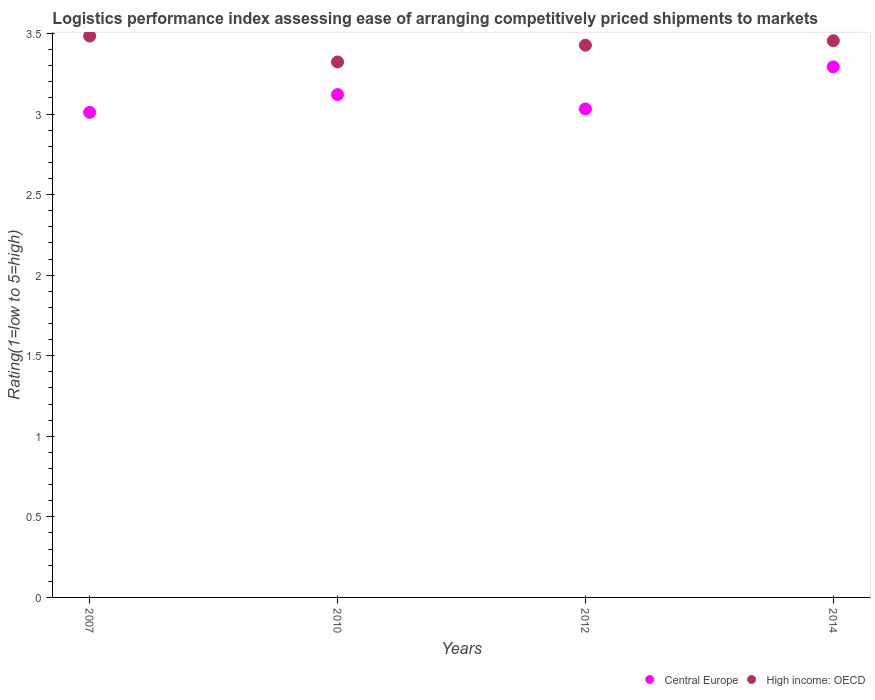What is the Logistic performance index in High income: OECD in 2010?
Provide a succinct answer. 3.32. Across all years, what is the maximum Logistic performance index in High income: OECD?
Ensure brevity in your answer.  3.48. Across all years, what is the minimum Logistic performance index in Central Europe?
Provide a short and direct response. 3.01. In which year was the Logistic performance index in High income: OECD maximum?
Offer a terse response. 2007. What is the total Logistic performance index in High income: OECD in the graph?
Provide a short and direct response. 13.69. What is the difference between the Logistic performance index in Central Europe in 2010 and that in 2014?
Provide a short and direct response. -0.17. What is the difference between the Logistic performance index in High income: OECD in 2014 and the Logistic performance index in Central Europe in 2010?
Your answer should be very brief. 0.33. What is the average Logistic performance index in High income: OECD per year?
Your answer should be very brief. 3.42. In the year 2010, what is the difference between the Logistic performance index in Central Europe and Logistic performance index in High income: OECD?
Offer a very short reply. -0.2. What is the ratio of the Logistic performance index in High income: OECD in 2007 to that in 2012?
Offer a very short reply. 1.02. Is the Logistic performance index in Central Europe in 2010 less than that in 2012?
Make the answer very short. No. Is the difference between the Logistic performance index in Central Europe in 2012 and 2014 greater than the difference between the Logistic performance index in High income: OECD in 2012 and 2014?
Keep it short and to the point. No. What is the difference between the highest and the second highest Logistic performance index in Central Europe?
Your answer should be very brief. 0.17. What is the difference between the highest and the lowest Logistic performance index in Central Europe?
Your response must be concise. 0.28. In how many years, is the Logistic performance index in High income: OECD greater than the average Logistic performance index in High income: OECD taken over all years?
Keep it short and to the point. 3. Is the sum of the Logistic performance index in Central Europe in 2010 and 2014 greater than the maximum Logistic performance index in High income: OECD across all years?
Your answer should be very brief. Yes. Does the Logistic performance index in Central Europe monotonically increase over the years?
Offer a very short reply. No. How many dotlines are there?
Ensure brevity in your answer.  2. Are the values on the major ticks of Y-axis written in scientific E-notation?
Your answer should be compact. No. Does the graph contain any zero values?
Provide a short and direct response. No. Does the graph contain grids?
Your answer should be very brief. No. Where does the legend appear in the graph?
Offer a very short reply. Bottom right. What is the title of the graph?
Give a very brief answer. Logistics performance index assessing ease of arranging competitively priced shipments to markets. What is the label or title of the Y-axis?
Your response must be concise. Rating(1=low to 5=high). What is the Rating(1=low to 5=high) in Central Europe in 2007?
Your response must be concise. 3.01. What is the Rating(1=low to 5=high) in High income: OECD in 2007?
Your answer should be very brief. 3.48. What is the Rating(1=low to 5=high) in Central Europe in 2010?
Your answer should be very brief. 3.12. What is the Rating(1=low to 5=high) in High income: OECD in 2010?
Provide a short and direct response. 3.32. What is the Rating(1=low to 5=high) of Central Europe in 2012?
Your answer should be very brief. 3.03. What is the Rating(1=low to 5=high) in High income: OECD in 2012?
Give a very brief answer. 3.43. What is the Rating(1=low to 5=high) of Central Europe in 2014?
Provide a succinct answer. 3.29. What is the Rating(1=low to 5=high) in High income: OECD in 2014?
Your answer should be compact. 3.45. Across all years, what is the maximum Rating(1=low to 5=high) of Central Europe?
Make the answer very short. 3.29. Across all years, what is the maximum Rating(1=low to 5=high) of High income: OECD?
Offer a terse response. 3.48. Across all years, what is the minimum Rating(1=low to 5=high) of Central Europe?
Provide a succinct answer. 3.01. Across all years, what is the minimum Rating(1=low to 5=high) of High income: OECD?
Your answer should be very brief. 3.32. What is the total Rating(1=low to 5=high) of Central Europe in the graph?
Offer a terse response. 12.46. What is the total Rating(1=low to 5=high) in High income: OECD in the graph?
Your answer should be very brief. 13.69. What is the difference between the Rating(1=low to 5=high) in Central Europe in 2007 and that in 2010?
Provide a succinct answer. -0.11. What is the difference between the Rating(1=low to 5=high) of High income: OECD in 2007 and that in 2010?
Ensure brevity in your answer.  0.16. What is the difference between the Rating(1=low to 5=high) of Central Europe in 2007 and that in 2012?
Offer a very short reply. -0.02. What is the difference between the Rating(1=low to 5=high) in High income: OECD in 2007 and that in 2012?
Give a very brief answer. 0.06. What is the difference between the Rating(1=low to 5=high) of Central Europe in 2007 and that in 2014?
Make the answer very short. -0.28. What is the difference between the Rating(1=low to 5=high) of High income: OECD in 2007 and that in 2014?
Make the answer very short. 0.03. What is the difference between the Rating(1=low to 5=high) in Central Europe in 2010 and that in 2012?
Your answer should be very brief. 0.09. What is the difference between the Rating(1=low to 5=high) in High income: OECD in 2010 and that in 2012?
Give a very brief answer. -0.1. What is the difference between the Rating(1=low to 5=high) of Central Europe in 2010 and that in 2014?
Give a very brief answer. -0.17. What is the difference between the Rating(1=low to 5=high) of High income: OECD in 2010 and that in 2014?
Keep it short and to the point. -0.13. What is the difference between the Rating(1=low to 5=high) of Central Europe in 2012 and that in 2014?
Make the answer very short. -0.26. What is the difference between the Rating(1=low to 5=high) of High income: OECD in 2012 and that in 2014?
Your answer should be compact. -0.03. What is the difference between the Rating(1=low to 5=high) in Central Europe in 2007 and the Rating(1=low to 5=high) in High income: OECD in 2010?
Ensure brevity in your answer.  -0.31. What is the difference between the Rating(1=low to 5=high) in Central Europe in 2007 and the Rating(1=low to 5=high) in High income: OECD in 2012?
Your response must be concise. -0.42. What is the difference between the Rating(1=low to 5=high) in Central Europe in 2007 and the Rating(1=low to 5=high) in High income: OECD in 2014?
Provide a succinct answer. -0.44. What is the difference between the Rating(1=low to 5=high) of Central Europe in 2010 and the Rating(1=low to 5=high) of High income: OECD in 2012?
Keep it short and to the point. -0.31. What is the difference between the Rating(1=low to 5=high) of Central Europe in 2010 and the Rating(1=low to 5=high) of High income: OECD in 2014?
Provide a short and direct response. -0.33. What is the difference between the Rating(1=low to 5=high) of Central Europe in 2012 and the Rating(1=low to 5=high) of High income: OECD in 2014?
Make the answer very short. -0.42. What is the average Rating(1=low to 5=high) of Central Europe per year?
Give a very brief answer. 3.11. What is the average Rating(1=low to 5=high) of High income: OECD per year?
Provide a short and direct response. 3.42. In the year 2007, what is the difference between the Rating(1=low to 5=high) in Central Europe and Rating(1=low to 5=high) in High income: OECD?
Offer a very short reply. -0.47. In the year 2010, what is the difference between the Rating(1=low to 5=high) of Central Europe and Rating(1=low to 5=high) of High income: OECD?
Offer a terse response. -0.2. In the year 2012, what is the difference between the Rating(1=low to 5=high) of Central Europe and Rating(1=low to 5=high) of High income: OECD?
Your answer should be very brief. -0.4. In the year 2014, what is the difference between the Rating(1=low to 5=high) of Central Europe and Rating(1=low to 5=high) of High income: OECD?
Ensure brevity in your answer.  -0.16. What is the ratio of the Rating(1=low to 5=high) of Central Europe in 2007 to that in 2010?
Your answer should be very brief. 0.96. What is the ratio of the Rating(1=low to 5=high) of High income: OECD in 2007 to that in 2010?
Ensure brevity in your answer.  1.05. What is the ratio of the Rating(1=low to 5=high) of Central Europe in 2007 to that in 2012?
Offer a terse response. 0.99. What is the ratio of the Rating(1=low to 5=high) of High income: OECD in 2007 to that in 2012?
Keep it short and to the point. 1.02. What is the ratio of the Rating(1=low to 5=high) in Central Europe in 2007 to that in 2014?
Provide a succinct answer. 0.91. What is the ratio of the Rating(1=low to 5=high) in High income: OECD in 2007 to that in 2014?
Provide a short and direct response. 1.01. What is the ratio of the Rating(1=low to 5=high) in Central Europe in 2010 to that in 2012?
Your answer should be very brief. 1.03. What is the ratio of the Rating(1=low to 5=high) in High income: OECD in 2010 to that in 2012?
Provide a succinct answer. 0.97. What is the ratio of the Rating(1=low to 5=high) in Central Europe in 2010 to that in 2014?
Your response must be concise. 0.95. What is the ratio of the Rating(1=low to 5=high) of High income: OECD in 2010 to that in 2014?
Give a very brief answer. 0.96. What is the ratio of the Rating(1=low to 5=high) in Central Europe in 2012 to that in 2014?
Make the answer very short. 0.92. What is the difference between the highest and the second highest Rating(1=low to 5=high) of Central Europe?
Your response must be concise. 0.17. What is the difference between the highest and the second highest Rating(1=low to 5=high) of High income: OECD?
Give a very brief answer. 0.03. What is the difference between the highest and the lowest Rating(1=low to 5=high) of Central Europe?
Your answer should be very brief. 0.28. What is the difference between the highest and the lowest Rating(1=low to 5=high) of High income: OECD?
Give a very brief answer. 0.16. 